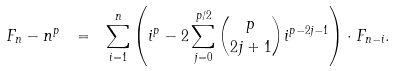Convert formula to latex. <formula><loc_0><loc_0><loc_500><loc_500>F _ { n } - n ^ { p } \ = \ \sum _ { i = 1 } ^ { n } \left ( i ^ { p } - 2 \sum _ { j = 0 } ^ { p / 2 } \binom { p } { 2 j + 1 } i ^ { p - 2 j - 1 } \right ) \cdot F _ { n - i } .</formula> 